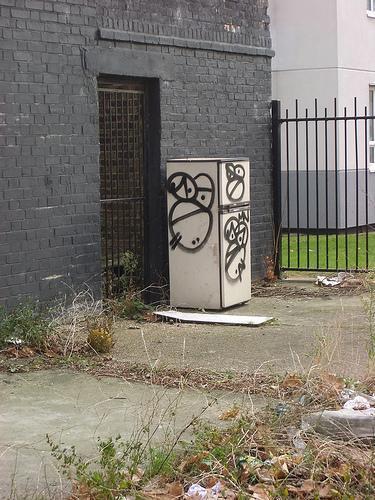How many refrigerators are there?
Give a very brief answer. 1. How many refrigerators are in this photo?
Give a very brief answer. 1. 